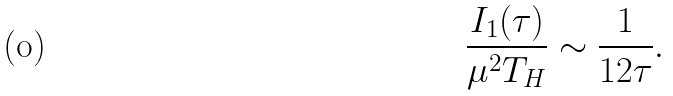Convert formula to latex. <formula><loc_0><loc_0><loc_500><loc_500>\frac { I _ { 1 } ( \tau ) } { \mu ^ { 2 } T _ { H } } \sim \frac { 1 } { 1 2 \tau } .</formula> 